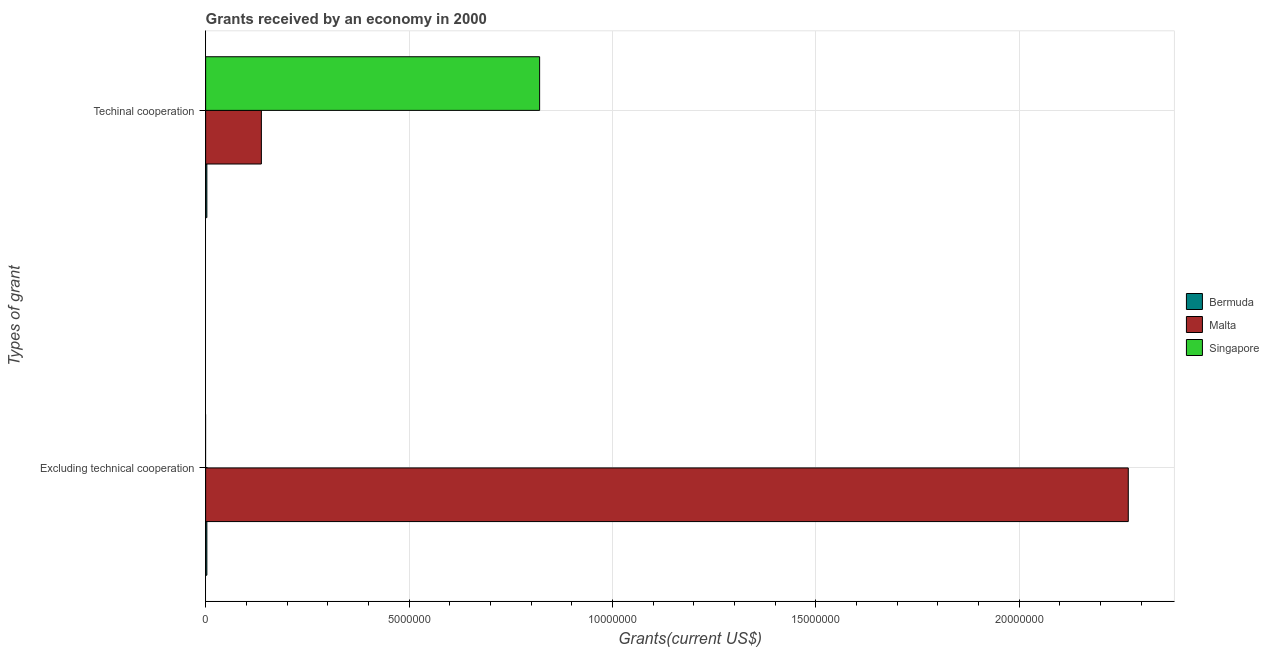How many different coloured bars are there?
Your answer should be very brief. 3. Are the number of bars per tick equal to the number of legend labels?
Keep it short and to the point. No. Are the number of bars on each tick of the Y-axis equal?
Offer a terse response. No. How many bars are there on the 2nd tick from the bottom?
Your answer should be very brief. 3. What is the label of the 1st group of bars from the top?
Give a very brief answer. Techinal cooperation. What is the amount of grants received(including technical cooperation) in Malta?
Provide a short and direct response. 1.37e+06. Across all countries, what is the maximum amount of grants received(excluding technical cooperation)?
Your answer should be compact. 2.27e+07. In which country was the amount of grants received(excluding technical cooperation) maximum?
Keep it short and to the point. Malta. What is the total amount of grants received(excluding technical cooperation) in the graph?
Provide a succinct answer. 2.27e+07. What is the difference between the amount of grants received(including technical cooperation) in Bermuda and that in Malta?
Keep it short and to the point. -1.34e+06. What is the difference between the amount of grants received(including technical cooperation) in Singapore and the amount of grants received(excluding technical cooperation) in Bermuda?
Provide a succinct answer. 8.18e+06. What is the average amount of grants received(including technical cooperation) per country?
Keep it short and to the point. 3.20e+06. What is the difference between the amount of grants received(excluding technical cooperation) and amount of grants received(including technical cooperation) in Bermuda?
Your answer should be compact. 0. What is the ratio of the amount of grants received(including technical cooperation) in Singapore to that in Malta?
Provide a short and direct response. 5.99. In how many countries, is the amount of grants received(including technical cooperation) greater than the average amount of grants received(including technical cooperation) taken over all countries?
Offer a terse response. 1. How many bars are there?
Your answer should be compact. 5. How many countries are there in the graph?
Offer a very short reply. 3. What is the difference between two consecutive major ticks on the X-axis?
Your response must be concise. 5.00e+06. Are the values on the major ticks of X-axis written in scientific E-notation?
Your answer should be very brief. No. Does the graph contain any zero values?
Provide a short and direct response. Yes. How many legend labels are there?
Your answer should be compact. 3. What is the title of the graph?
Provide a short and direct response. Grants received by an economy in 2000. Does "Romania" appear as one of the legend labels in the graph?
Make the answer very short. No. What is the label or title of the X-axis?
Offer a very short reply. Grants(current US$). What is the label or title of the Y-axis?
Give a very brief answer. Types of grant. What is the Grants(current US$) in Bermuda in Excluding technical cooperation?
Your response must be concise. 3.00e+04. What is the Grants(current US$) of Malta in Excluding technical cooperation?
Offer a terse response. 2.27e+07. What is the Grants(current US$) of Bermuda in Techinal cooperation?
Your answer should be very brief. 3.00e+04. What is the Grants(current US$) in Malta in Techinal cooperation?
Make the answer very short. 1.37e+06. What is the Grants(current US$) in Singapore in Techinal cooperation?
Your response must be concise. 8.21e+06. Across all Types of grant, what is the maximum Grants(current US$) in Malta?
Give a very brief answer. 2.27e+07. Across all Types of grant, what is the maximum Grants(current US$) in Singapore?
Your answer should be very brief. 8.21e+06. Across all Types of grant, what is the minimum Grants(current US$) of Malta?
Your answer should be very brief. 1.37e+06. What is the total Grants(current US$) in Bermuda in the graph?
Keep it short and to the point. 6.00e+04. What is the total Grants(current US$) in Malta in the graph?
Ensure brevity in your answer.  2.40e+07. What is the total Grants(current US$) in Singapore in the graph?
Your response must be concise. 8.21e+06. What is the difference between the Grants(current US$) in Malta in Excluding technical cooperation and that in Techinal cooperation?
Your response must be concise. 2.13e+07. What is the difference between the Grants(current US$) of Bermuda in Excluding technical cooperation and the Grants(current US$) of Malta in Techinal cooperation?
Provide a short and direct response. -1.34e+06. What is the difference between the Grants(current US$) of Bermuda in Excluding technical cooperation and the Grants(current US$) of Singapore in Techinal cooperation?
Make the answer very short. -8.18e+06. What is the difference between the Grants(current US$) of Malta in Excluding technical cooperation and the Grants(current US$) of Singapore in Techinal cooperation?
Give a very brief answer. 1.45e+07. What is the average Grants(current US$) in Malta per Types of grant?
Your response must be concise. 1.20e+07. What is the average Grants(current US$) in Singapore per Types of grant?
Your response must be concise. 4.10e+06. What is the difference between the Grants(current US$) in Bermuda and Grants(current US$) in Malta in Excluding technical cooperation?
Keep it short and to the point. -2.26e+07. What is the difference between the Grants(current US$) of Bermuda and Grants(current US$) of Malta in Techinal cooperation?
Offer a terse response. -1.34e+06. What is the difference between the Grants(current US$) of Bermuda and Grants(current US$) of Singapore in Techinal cooperation?
Ensure brevity in your answer.  -8.18e+06. What is the difference between the Grants(current US$) of Malta and Grants(current US$) of Singapore in Techinal cooperation?
Offer a very short reply. -6.84e+06. What is the ratio of the Grants(current US$) in Bermuda in Excluding technical cooperation to that in Techinal cooperation?
Provide a short and direct response. 1. What is the ratio of the Grants(current US$) in Malta in Excluding technical cooperation to that in Techinal cooperation?
Your response must be concise. 16.55. What is the difference between the highest and the second highest Grants(current US$) in Malta?
Provide a succinct answer. 2.13e+07. What is the difference between the highest and the lowest Grants(current US$) of Malta?
Provide a succinct answer. 2.13e+07. What is the difference between the highest and the lowest Grants(current US$) in Singapore?
Your response must be concise. 8.21e+06. 